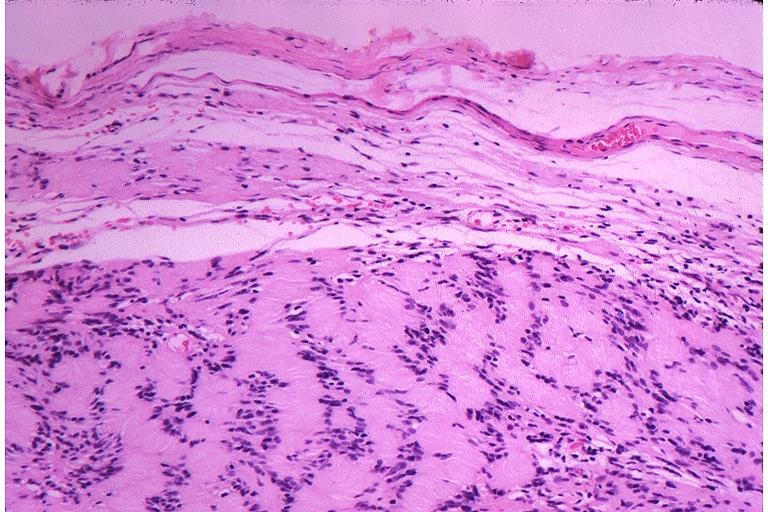what is present?
Answer the question using a single word or phrase. Oral 